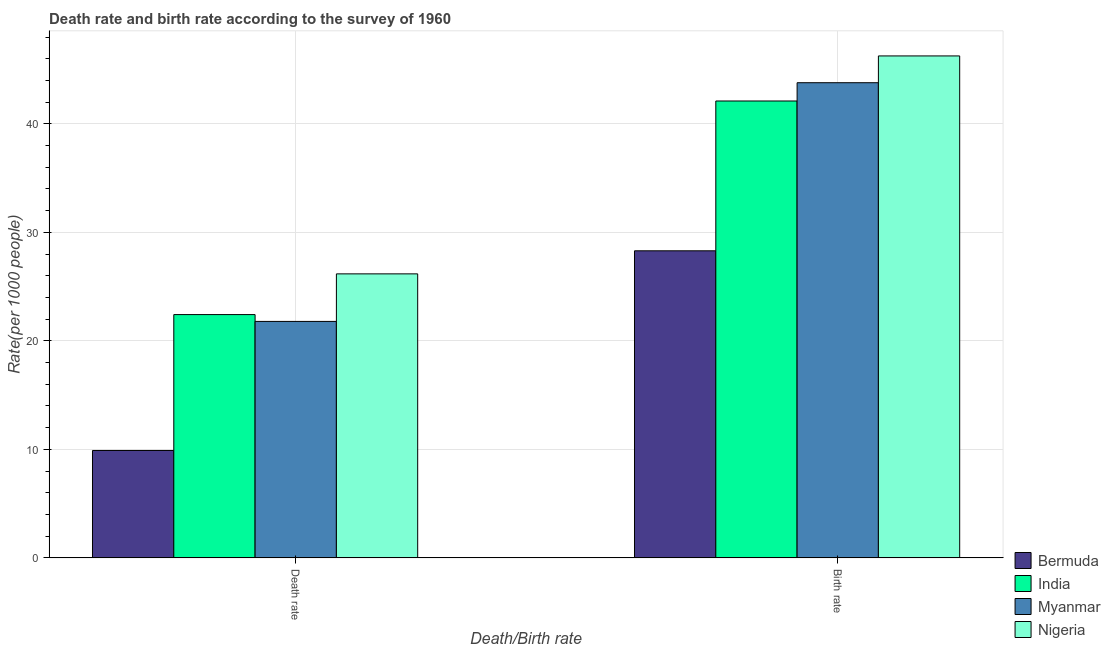How many different coloured bars are there?
Make the answer very short. 4. Are the number of bars per tick equal to the number of legend labels?
Offer a terse response. Yes. What is the label of the 1st group of bars from the left?
Provide a short and direct response. Death rate. What is the birth rate in Bermuda?
Make the answer very short. 28.3. Across all countries, what is the maximum death rate?
Provide a succinct answer. 26.18. Across all countries, what is the minimum birth rate?
Your answer should be very brief. 28.3. In which country was the death rate maximum?
Make the answer very short. Nigeria. In which country was the death rate minimum?
Offer a very short reply. Bermuda. What is the total death rate in the graph?
Offer a terse response. 80.29. What is the difference between the death rate in Myanmar and that in India?
Your response must be concise. -0.63. What is the difference between the death rate in Bermuda and the birth rate in Nigeria?
Give a very brief answer. -36.36. What is the average birth rate per country?
Make the answer very short. 40.11. What is the difference between the death rate and birth rate in India?
Your answer should be compact. -19.68. What is the ratio of the death rate in Nigeria to that in Myanmar?
Keep it short and to the point. 1.2. Is the death rate in Nigeria less than that in Myanmar?
Give a very brief answer. No. What does the 3rd bar from the left in Birth rate represents?
Your response must be concise. Myanmar. What does the 2nd bar from the right in Death rate represents?
Your response must be concise. Myanmar. Are all the bars in the graph horizontal?
Provide a short and direct response. No. Are the values on the major ticks of Y-axis written in scientific E-notation?
Your response must be concise. No. Does the graph contain any zero values?
Give a very brief answer. No. How many legend labels are there?
Keep it short and to the point. 4. What is the title of the graph?
Your response must be concise. Death rate and birth rate according to the survey of 1960. Does "Bangladesh" appear as one of the legend labels in the graph?
Offer a very short reply. No. What is the label or title of the X-axis?
Make the answer very short. Death/Birth rate. What is the label or title of the Y-axis?
Offer a terse response. Rate(per 1000 people). What is the Rate(per 1000 people) in Bermuda in Death rate?
Make the answer very short. 9.9. What is the Rate(per 1000 people) of India in Death rate?
Keep it short and to the point. 22.42. What is the Rate(per 1000 people) of Myanmar in Death rate?
Offer a terse response. 21.79. What is the Rate(per 1000 people) of Nigeria in Death rate?
Make the answer very short. 26.18. What is the Rate(per 1000 people) in Bermuda in Birth rate?
Provide a short and direct response. 28.3. What is the Rate(per 1000 people) of India in Birth rate?
Provide a succinct answer. 42.11. What is the Rate(per 1000 people) of Myanmar in Birth rate?
Your answer should be very brief. 43.79. What is the Rate(per 1000 people) of Nigeria in Birth rate?
Provide a succinct answer. 46.26. Across all Death/Birth rate, what is the maximum Rate(per 1000 people) in Bermuda?
Provide a succinct answer. 28.3. Across all Death/Birth rate, what is the maximum Rate(per 1000 people) in India?
Make the answer very short. 42.11. Across all Death/Birth rate, what is the maximum Rate(per 1000 people) of Myanmar?
Ensure brevity in your answer.  43.79. Across all Death/Birth rate, what is the maximum Rate(per 1000 people) in Nigeria?
Make the answer very short. 46.26. Across all Death/Birth rate, what is the minimum Rate(per 1000 people) in India?
Ensure brevity in your answer.  22.42. Across all Death/Birth rate, what is the minimum Rate(per 1000 people) of Myanmar?
Provide a succinct answer. 21.79. Across all Death/Birth rate, what is the minimum Rate(per 1000 people) of Nigeria?
Keep it short and to the point. 26.18. What is the total Rate(per 1000 people) of Bermuda in the graph?
Offer a very short reply. 38.2. What is the total Rate(per 1000 people) in India in the graph?
Make the answer very short. 64.53. What is the total Rate(per 1000 people) in Myanmar in the graph?
Your response must be concise. 65.58. What is the total Rate(per 1000 people) in Nigeria in the graph?
Your answer should be compact. 72.44. What is the difference between the Rate(per 1000 people) of Bermuda in Death rate and that in Birth rate?
Make the answer very short. -18.4. What is the difference between the Rate(per 1000 people) in India in Death rate and that in Birth rate?
Give a very brief answer. -19.68. What is the difference between the Rate(per 1000 people) of Myanmar in Death rate and that in Birth rate?
Your response must be concise. -22. What is the difference between the Rate(per 1000 people) of Nigeria in Death rate and that in Birth rate?
Make the answer very short. -20.09. What is the difference between the Rate(per 1000 people) in Bermuda in Death rate and the Rate(per 1000 people) in India in Birth rate?
Your response must be concise. -32.21. What is the difference between the Rate(per 1000 people) of Bermuda in Death rate and the Rate(per 1000 people) of Myanmar in Birth rate?
Ensure brevity in your answer.  -33.89. What is the difference between the Rate(per 1000 people) in Bermuda in Death rate and the Rate(per 1000 people) in Nigeria in Birth rate?
Offer a terse response. -36.36. What is the difference between the Rate(per 1000 people) in India in Death rate and the Rate(per 1000 people) in Myanmar in Birth rate?
Give a very brief answer. -21.37. What is the difference between the Rate(per 1000 people) in India in Death rate and the Rate(per 1000 people) in Nigeria in Birth rate?
Your answer should be very brief. -23.84. What is the difference between the Rate(per 1000 people) of Myanmar in Death rate and the Rate(per 1000 people) of Nigeria in Birth rate?
Ensure brevity in your answer.  -24.47. What is the average Rate(per 1000 people) of Bermuda per Death/Birth rate?
Ensure brevity in your answer.  19.1. What is the average Rate(per 1000 people) of India per Death/Birth rate?
Offer a very short reply. 32.27. What is the average Rate(per 1000 people) of Myanmar per Death/Birth rate?
Your answer should be compact. 32.79. What is the average Rate(per 1000 people) of Nigeria per Death/Birth rate?
Provide a succinct answer. 36.22. What is the difference between the Rate(per 1000 people) of Bermuda and Rate(per 1000 people) of India in Death rate?
Your answer should be very brief. -12.52. What is the difference between the Rate(per 1000 people) in Bermuda and Rate(per 1000 people) in Myanmar in Death rate?
Your answer should be very brief. -11.89. What is the difference between the Rate(per 1000 people) in Bermuda and Rate(per 1000 people) in Nigeria in Death rate?
Your answer should be compact. -16.27. What is the difference between the Rate(per 1000 people) of India and Rate(per 1000 people) of Myanmar in Death rate?
Offer a very short reply. 0.63. What is the difference between the Rate(per 1000 people) of India and Rate(per 1000 people) of Nigeria in Death rate?
Provide a succinct answer. -3.75. What is the difference between the Rate(per 1000 people) of Myanmar and Rate(per 1000 people) of Nigeria in Death rate?
Give a very brief answer. -4.38. What is the difference between the Rate(per 1000 people) of Bermuda and Rate(per 1000 people) of India in Birth rate?
Keep it short and to the point. -13.81. What is the difference between the Rate(per 1000 people) of Bermuda and Rate(per 1000 people) of Myanmar in Birth rate?
Your answer should be very brief. -15.49. What is the difference between the Rate(per 1000 people) in Bermuda and Rate(per 1000 people) in Nigeria in Birth rate?
Ensure brevity in your answer.  -17.96. What is the difference between the Rate(per 1000 people) of India and Rate(per 1000 people) of Myanmar in Birth rate?
Provide a short and direct response. -1.68. What is the difference between the Rate(per 1000 people) in India and Rate(per 1000 people) in Nigeria in Birth rate?
Your response must be concise. -4.15. What is the difference between the Rate(per 1000 people) of Myanmar and Rate(per 1000 people) of Nigeria in Birth rate?
Keep it short and to the point. -2.47. What is the ratio of the Rate(per 1000 people) of Bermuda in Death rate to that in Birth rate?
Provide a short and direct response. 0.35. What is the ratio of the Rate(per 1000 people) of India in Death rate to that in Birth rate?
Make the answer very short. 0.53. What is the ratio of the Rate(per 1000 people) in Myanmar in Death rate to that in Birth rate?
Your answer should be very brief. 0.5. What is the ratio of the Rate(per 1000 people) in Nigeria in Death rate to that in Birth rate?
Your answer should be compact. 0.57. What is the difference between the highest and the second highest Rate(per 1000 people) in India?
Provide a short and direct response. 19.68. What is the difference between the highest and the second highest Rate(per 1000 people) in Myanmar?
Give a very brief answer. 22. What is the difference between the highest and the second highest Rate(per 1000 people) of Nigeria?
Provide a succinct answer. 20.09. What is the difference between the highest and the lowest Rate(per 1000 people) in Bermuda?
Make the answer very short. 18.4. What is the difference between the highest and the lowest Rate(per 1000 people) in India?
Keep it short and to the point. 19.68. What is the difference between the highest and the lowest Rate(per 1000 people) in Myanmar?
Give a very brief answer. 22. What is the difference between the highest and the lowest Rate(per 1000 people) of Nigeria?
Give a very brief answer. 20.09. 